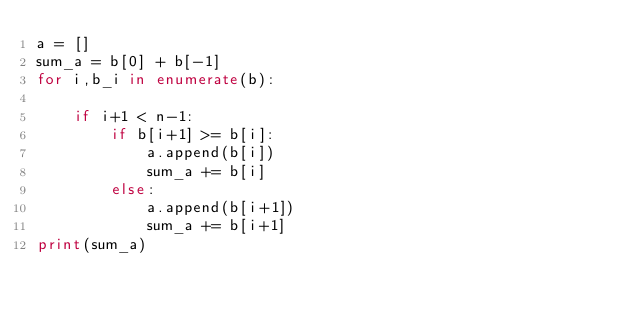<code> <loc_0><loc_0><loc_500><loc_500><_Python_>a = []
sum_a = b[0] + b[-1]
for i,b_i in enumerate(b):
    
    if i+1 < n-1:
        if b[i+1] >= b[i]:
            a.append(b[i])
            sum_a += b[i]
        else:
            a.append(b[i+1])
            sum_a += b[i+1]
print(sum_a)</code> 